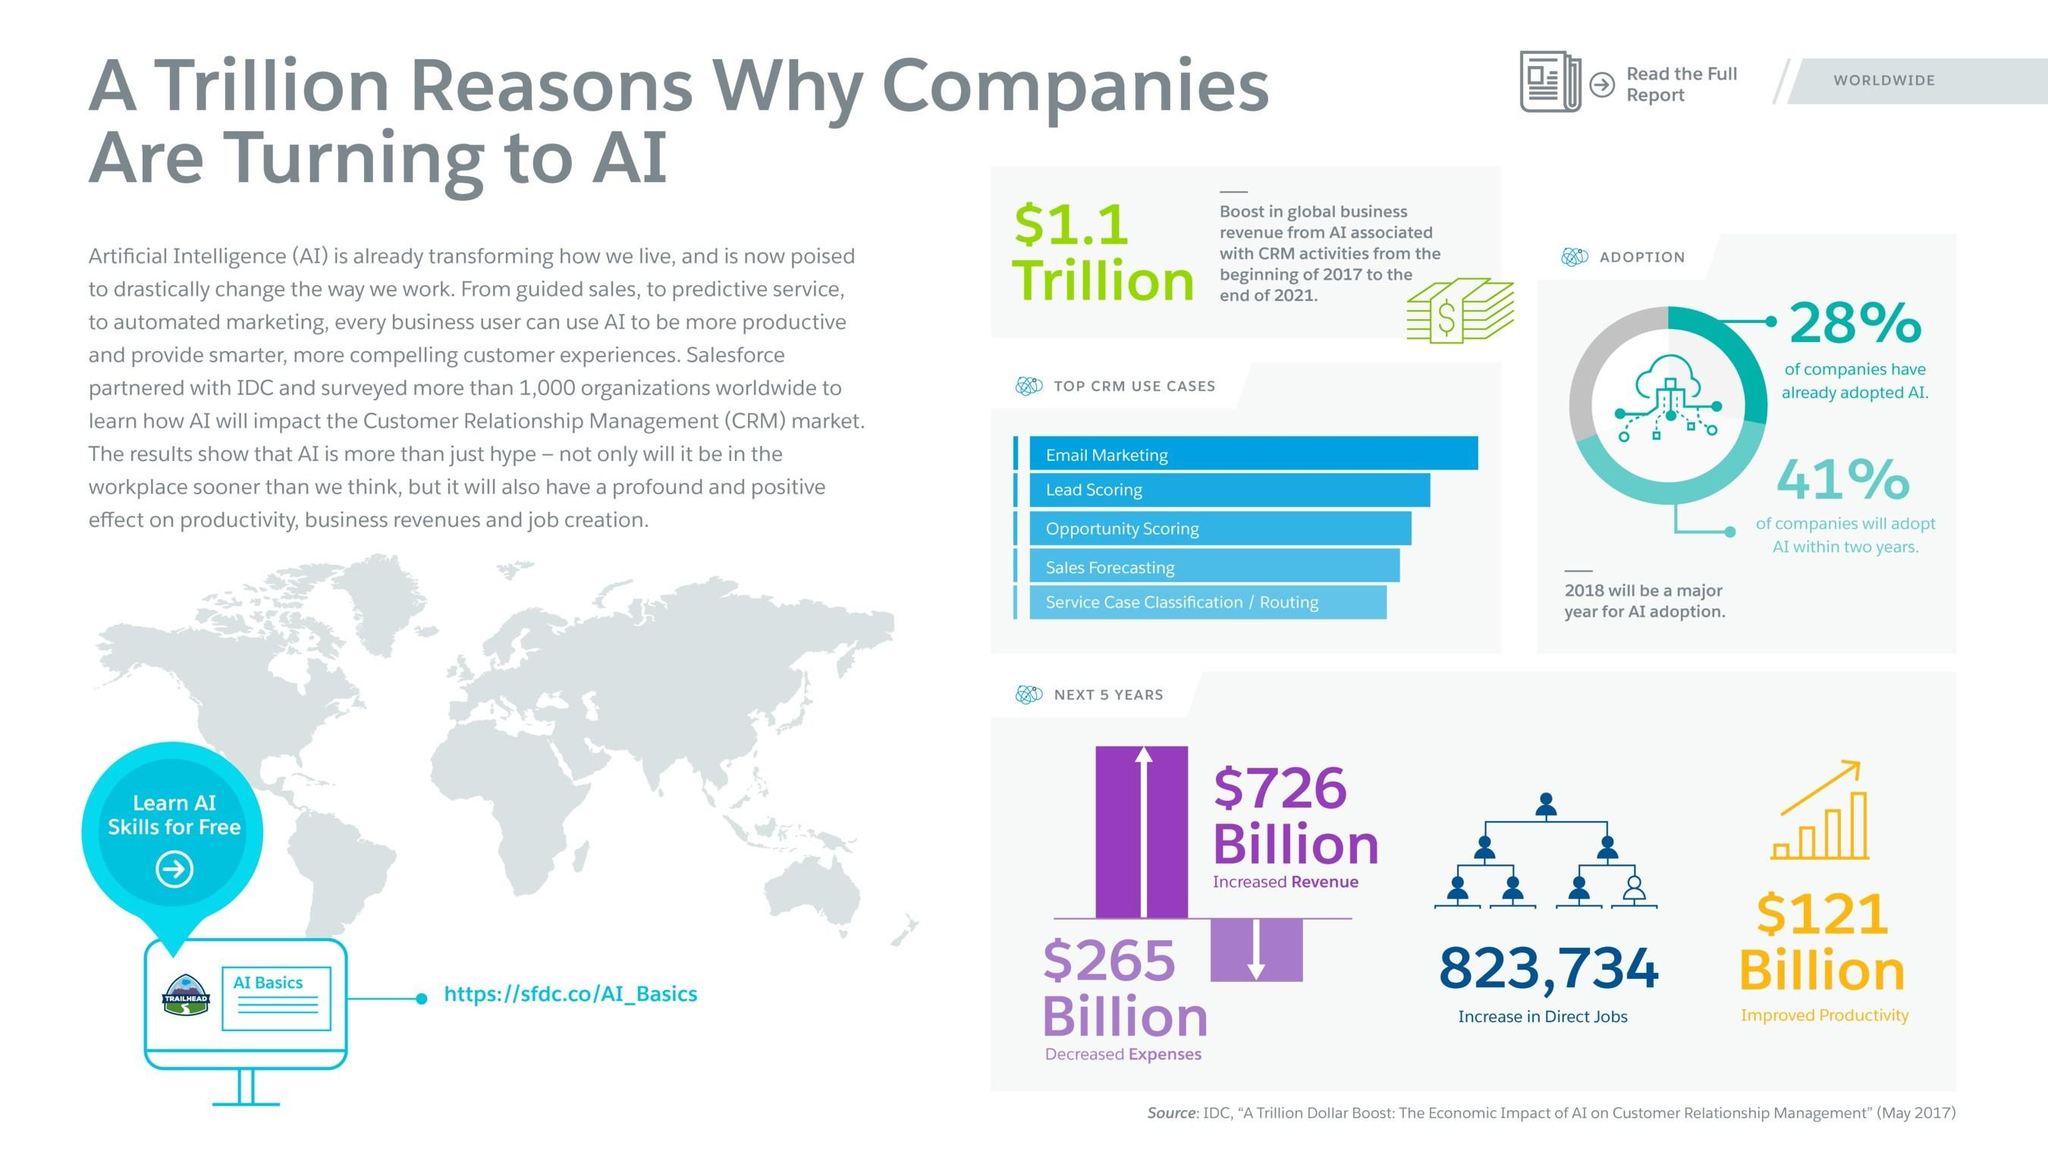Point out several critical features in this image. The adoption of AI is expected to lead to an increase of 823,734 direct jobs in the market within the next five years. 41% of companies are expected to adopt AI within the next two years. According to predictions, the adoption of AI is expected to result in a staggering $726 billion growth in revenue over the next five years. According to a recent survey, 28% of companies have already adopted AI. 